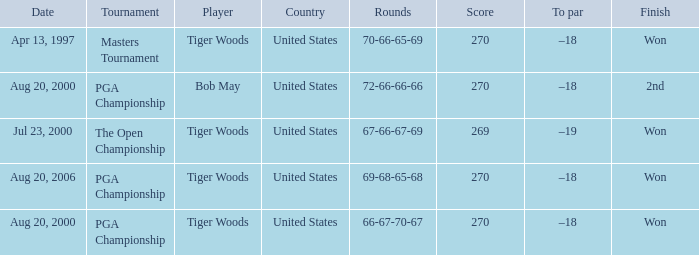What is the worst (highest) score? 270.0. 